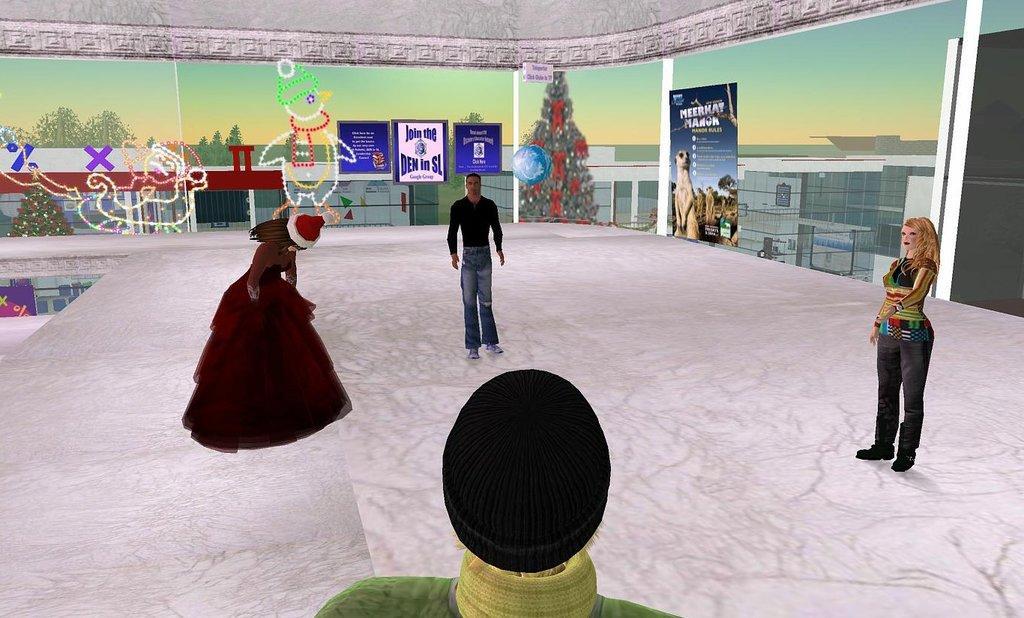Describe this image in one or two sentences. This is an animated image, in this picture there are people on the floor and we can see decorative objects, boards, buildings, trees and sky. 